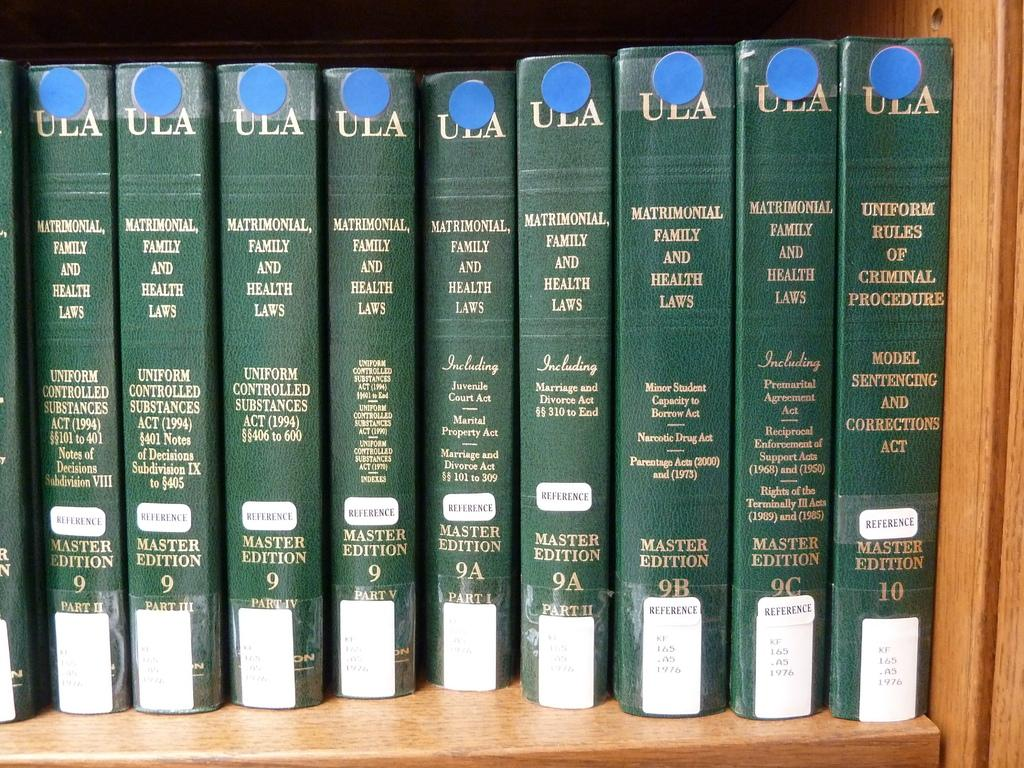<image>
Write a terse but informative summary of the picture. A row of legal books that are all master editions. 